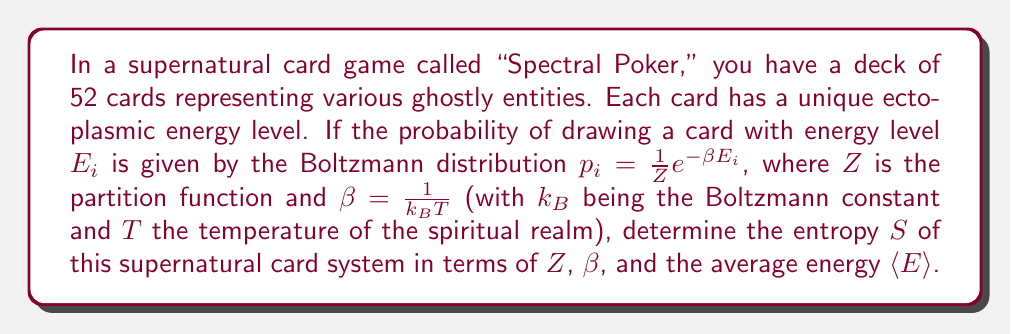Could you help me with this problem? Let's approach this step-by-step:

1) The entropy in statistical mechanics is given by the Gibbs entropy formula:

   $$S = -k_B \sum_i p_i \ln p_i$$

2) We're given that the probabilities follow the Boltzmann distribution:

   $$p_i = \frac{1}{Z} e^{-\beta E_i}$$

3) Let's substitute this into the entropy formula:

   $$S = -k_B \sum_i \frac{1}{Z} e^{-\beta E_i} \ln \left(\frac{1}{Z} e^{-\beta E_i}\right)$$

4) We can separate the logarithm:

   $$S = -k_B \sum_i \frac{1}{Z} e^{-\beta E_i} [\ln(1/Z) - \beta E_i]$$

5) Distribute the sum:

   $$S = -k_B \left[\ln(1/Z) \sum_i \frac{1}{Z} e^{-\beta E_i} - \beta \sum_i \frac{1}{Z} e^{-\beta E_i} E_i\right]$$

6) Recognize that $\sum_i \frac{1}{Z} e^{-\beta E_i} = 1$ (sum of all probabilities):

   $$S = -k_B [\ln(1/Z) - \beta \langle E \rangle]$$

   Where $\langle E \rangle = \sum_i \frac{1}{Z} e^{-\beta E_i} E_i$ is the average energy.

7) Simplify:

   $$S = k_B [\ln Z + \beta \langle E \rangle]$$

8) Recall that $\beta = \frac{1}{k_B T}$, so $k_B \beta = \frac{1}{T}$:

   $$S = k_B \ln Z + \frac{\langle E \rangle}{T}$$

This is our final expression for the entropy of the supernatural card system.
Answer: $S = k_B \ln Z + \frac{\langle E \rangle}{T}$ 